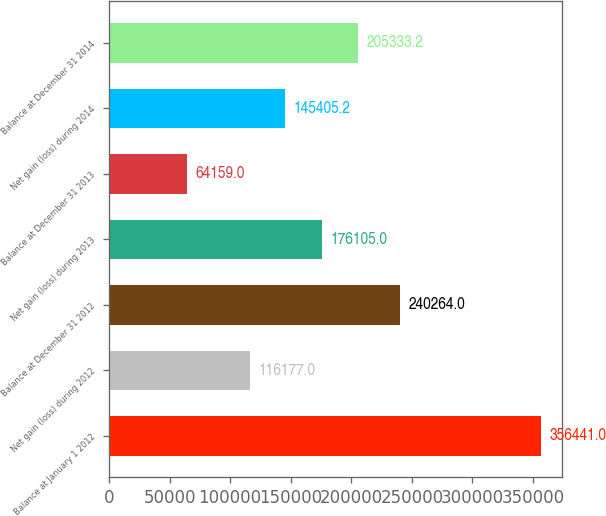Convert chart to OTSL. <chart><loc_0><loc_0><loc_500><loc_500><bar_chart><fcel>Balance at January 1 2012<fcel>Net gain (loss) during 2012<fcel>Balance at December 31 2012<fcel>Net gain (loss) during 2013<fcel>Balance at December 31 2013<fcel>Net gain (loss) during 2014<fcel>Balance at December 31 2014<nl><fcel>356441<fcel>116177<fcel>240264<fcel>176105<fcel>64159<fcel>145405<fcel>205333<nl></chart> 